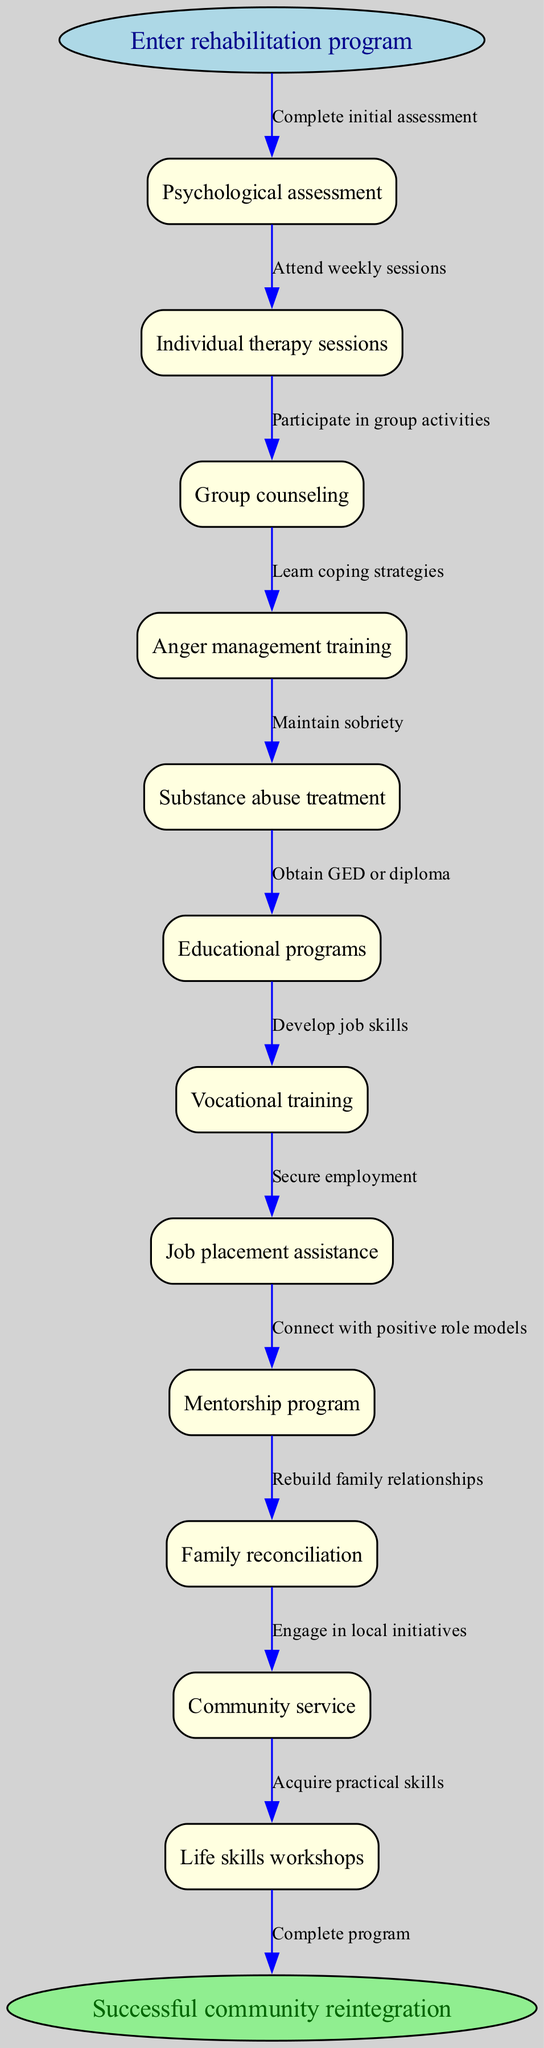What is the starting point of the rehabilitation pathway? The diagram indicates that the starting point of the pathway is "Enter rehabilitation program." This is explicitly stated in the 'start' node of the diagram.
Answer: Enter rehabilitation program How many nodes are there in the pathway? The diagram lists a total of 13 nodes, including the start and end nodes. There are 11 intermediate nodes (the steps of the pathway).
Answer: 13 What type of therapy is included in the pathway? The diagram lists "Individual therapy sessions" as one of its key components, indicating that this type of therapy is part of the rehabilitation process.
Answer: Individual therapy sessions What is the last step before successful community reintegration? Referring to the edges leading from the last intermediate node to the end node, the last step is to "Complete program," marking the transition to successful reintegration.
Answer: Complete program Which node comes after "Psychological assessment"? The flow of the pathway shows that "Individual therapy sessions" follows directly after "Psychological assessment," demonstrating the sequence of steps in the rehabilitation process.
Answer: Individual therapy sessions What is one of the skills participants will acquire during the program? According to the nodes, "Life skills workshops" are included in the program, indicating that participants will acquire important life skills as part of their rehabilitation.
Answer: Life skills workshops After "Job placement assistance," what is the next step in the pathway? The pathway indicates that "Mentorship program" follows after "Job placement assistance," showing the logical progression of support services offered.
Answer: Mentorship program How many edges are there in the rehabilitation pathway? The diagram includes a total of 12 edges connecting the nodes, representing the different steps and transitions in the rehabilitation process from start to finish.
Answer: 12 What type of training is provided in addition to substance abuse treatment? The diagram specifies "Vocational training" as a key component offered alongside substance abuse treatment, highlighting the dual focus of the rehabilitation program.
Answer: Vocational training 